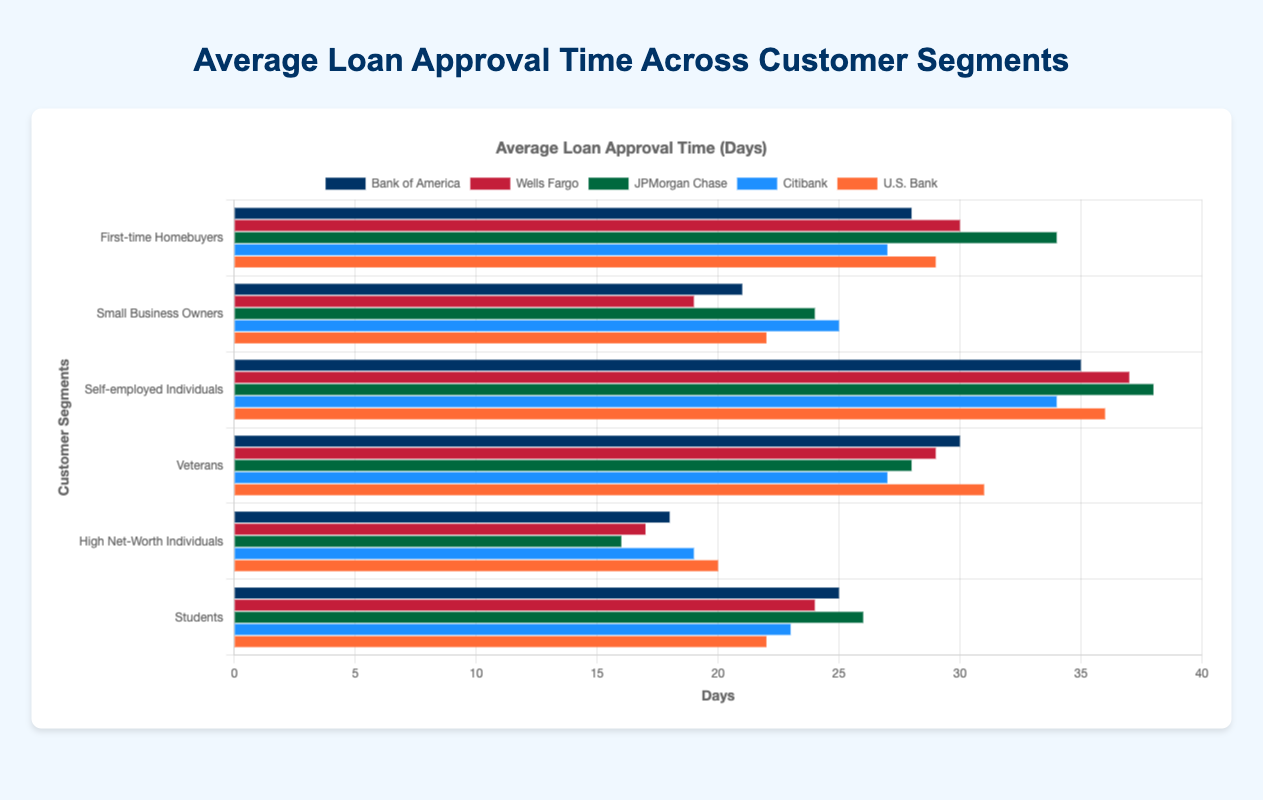Which customer segment has the highest average loan approval time at JPMorgan Chase? To find the segment with the highest average loan approval time for JPMorgan Chase, check each segment's values: 34, 24, 38, 28, 16, 26. The highest value is for Self-employed Individuals, with 38 days.
Answer: Self-employed Individuals Which bank has the shortest approval time for High Net-Worth Individuals? Look at the approval times for High Net-Worth Individuals across all banks: 18 (Bank of America), 17 (Wells Fargo), 16 (JPMorgan Chase), 19 (Citibank), and 20 (U.S. Bank). The shortest time is 16 days by JPMorgan Chase.
Answer: JPMorgan Chase What is the difference in approval time for Small Business Owners between Citibank and Bank of America? The approval time for Small Business Owners is 25 days at Citibank and 21 days at Bank of America. The difference is 25 - 21 = 4 days.
Answer: 4 days Which bank on average processes loans faster for Veterans? Compare the values for Veterans among the banks: 30 (Bank of America), 29 (Wells Fargo), 28 (JPMorgan Chase), 27 (Citibank), and 31 (U.S. Bank). Citibank has the shortest time with 27 days.
Answer: Citibank Which customer segment has the most variable loan approval times across the banks? For each segment, check the range of approval times (max - min):
- First-time Homebuyers: 34 - 27 = 7
- Small Business Owners: 25 - 19 = 6
- Self-employed Individuals: 38 - 34 = 4
- Veterans: 31 - 27 = 4
- High Net-Worth Individuals: 20 - 16 = 4
- Students: 26 - 22 = 4
First-time Homebuyers have the highest range of 7 days.
Answer: First-time Homebuyers What is the average loan approval time for Students across all banks? Sum the approval times for Students: 25 (Bank of America) + 24 (Wells Fargo) + 26 (JPMorgan Chase) + 23 (Citibank) + 22 (U.S. Bank) = 120. Divide by the number of banks (5): 120 / 5 = 24 days.
Answer: 24 days Does Wells Fargo process loans faster for Small Business Owners or Veterans? Compare the approval times for Wells Fargo: 19 days for Small Business Owners and 29 days for Veterans. Therefore, Wells Fargo processes faster for Small Business Owners.
Answer: Small Business Owners Rank the banks from fastest to slowest approval time for First-time Homebuyers. List the approval times for First-time Homebuyers by bank: Citibank (27 days), Bank of America (28 days), U.S. Bank (29 days), Wells Fargo (30 days), JPMorgan Chase (34 days). Arrange from least to greatest: Citibank, Bank of America, U.S. Bank, Wells Fargo, JPMorgan Chase.
Answer: Citibank, Bank of America, U.S. Bank, Wells Fargo, JPMorgan Chase 